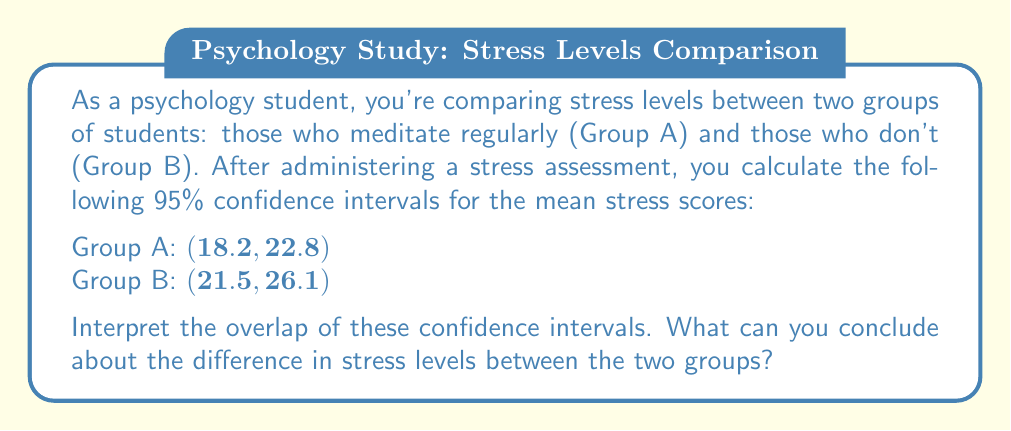Show me your answer to this math problem. To interpret the overlap of confidence intervals, we need to follow these steps:

1. Identify the overlap:
   The intervals overlap between 21.5 and 22.8.

2. Assess the extent of overlap:
   The overlap is relatively small compared to the total range of both intervals.

3. Interpret the overlap:
   a) When confidence intervals overlap, we cannot conclude with certainty that there is a statistically significant difference between the two groups at the 0.05 level.
   b) However, the small overlap suggests that there might be a difference, but we would need to conduct a formal hypothesis test to confirm.

4. Consider the practical significance:
   The non-meditating group (B) appears to have a higher stress level, as its entire interval is shifted towards higher values compared to the meditating group (A).

5. Limitations:
   a) Confidence intervals provide a range of plausible values for the population mean, not a single point estimate.
   b) The amount of overlap doesn't directly translate to p-values or effect sizes.

6. Conclusion:
   While we can't definitively state there's a significant difference, the small overlap and relative positions of the intervals suggest that students who don't meditate (Group B) may have higher stress levels than those who do (Group A).
Answer: The overlapping confidence intervals suggest a possible difference in stress levels between meditating and non-meditating students, but a formal hypothesis test is needed for confirmation. 